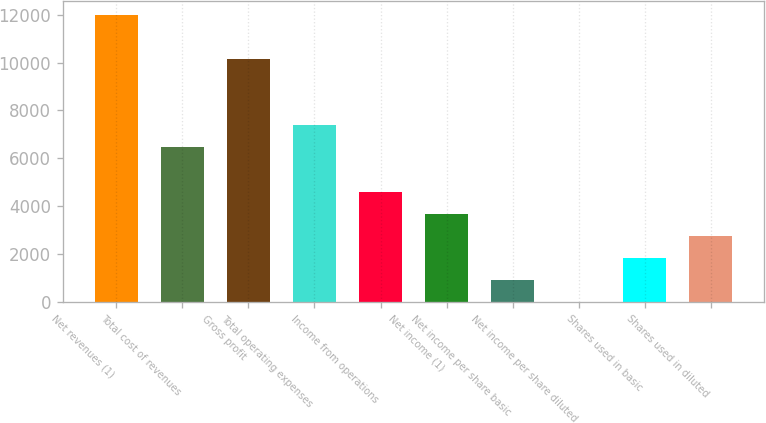Convert chart. <chart><loc_0><loc_0><loc_500><loc_500><bar_chart><fcel>Net revenues (1)<fcel>Total cost of revenues<fcel>Gross profit<fcel>Total operating expenses<fcel>Income from operations<fcel>Net income (1)<fcel>Net income per share basic<fcel>Net income per share diluted<fcel>Shares used in basic<fcel>Shares used in diluted<nl><fcel>11984.5<fcel>6454.01<fcel>10141<fcel>7375.75<fcel>4610.53<fcel>3688.79<fcel>923.57<fcel>1.83<fcel>1845.31<fcel>2767.05<nl></chart> 